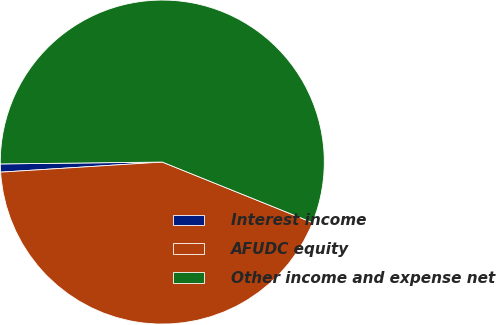Convert chart to OTSL. <chart><loc_0><loc_0><loc_500><loc_500><pie_chart><fcel>Interest income<fcel>AFUDC equity<fcel>Other income and expense net<nl><fcel>0.81%<fcel>42.91%<fcel>56.28%<nl></chart> 